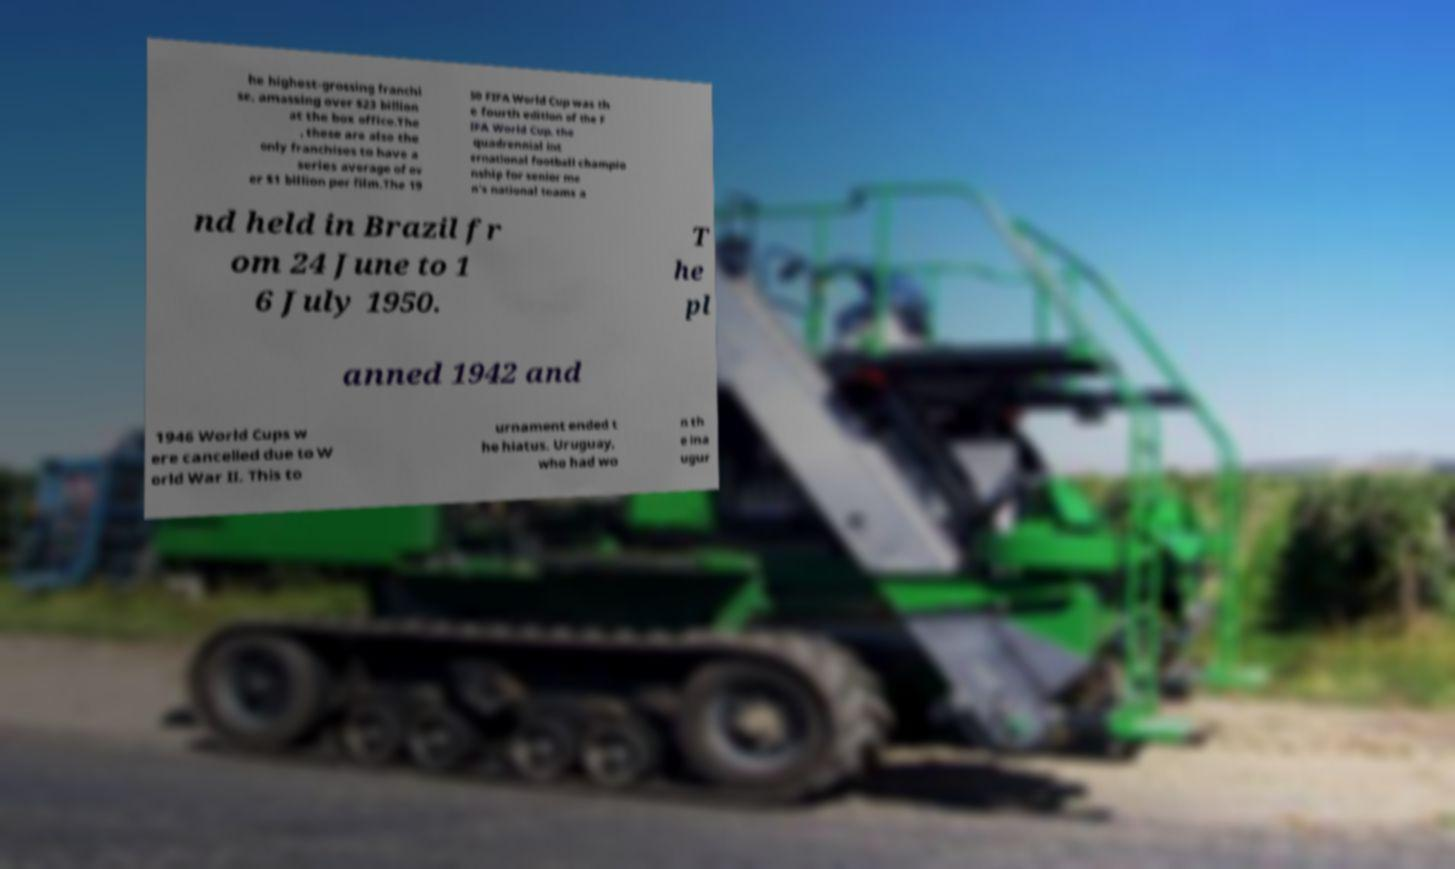There's text embedded in this image that I need extracted. Can you transcribe it verbatim? he highest-grossing franchi se, amassing over $23 billion at the box office.The , these are also the only franchises to have a series average of ov er $1 billion per film.The 19 50 FIFA World Cup was th e fourth edition of the F IFA World Cup, the quadrennial int ernational football champio nship for senior me n's national teams a nd held in Brazil fr om 24 June to 1 6 July 1950. T he pl anned 1942 and 1946 World Cups w ere cancelled due to W orld War II. This to urnament ended t he hiatus. Uruguay, who had wo n th e ina ugur 